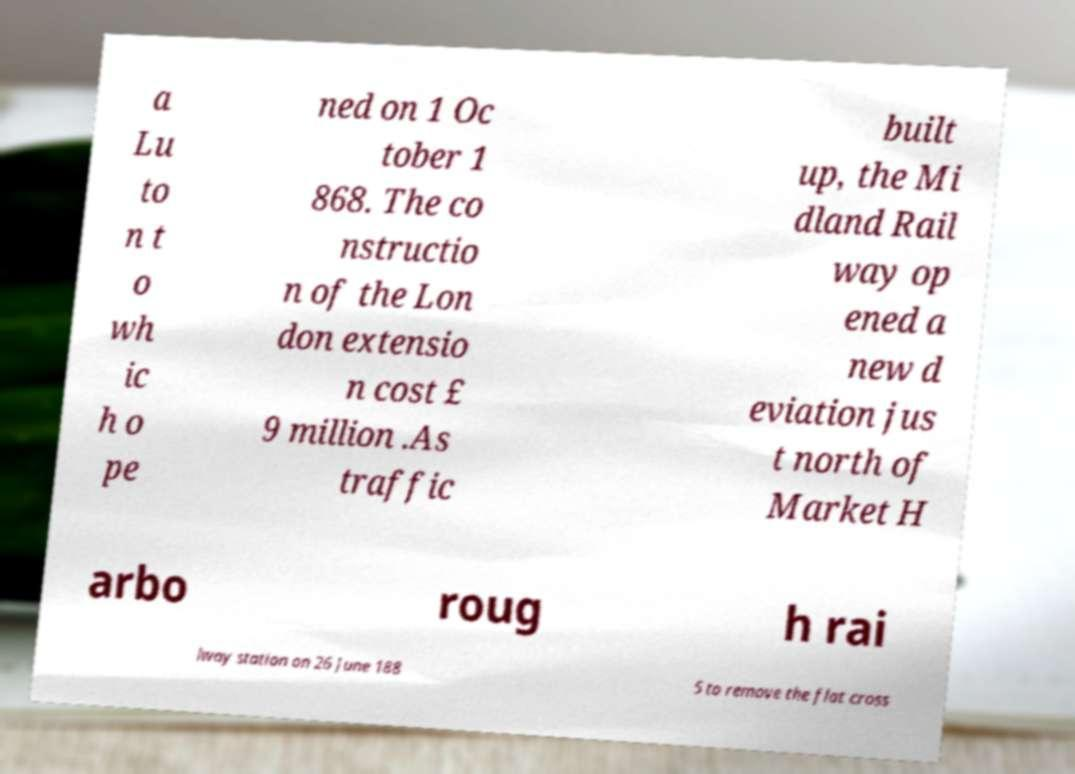Could you assist in decoding the text presented in this image and type it out clearly? a Lu to n t o wh ic h o pe ned on 1 Oc tober 1 868. The co nstructio n of the Lon don extensio n cost £ 9 million .As traffic built up, the Mi dland Rail way op ened a new d eviation jus t north of Market H arbo roug h rai lway station on 26 June 188 5 to remove the flat cross 